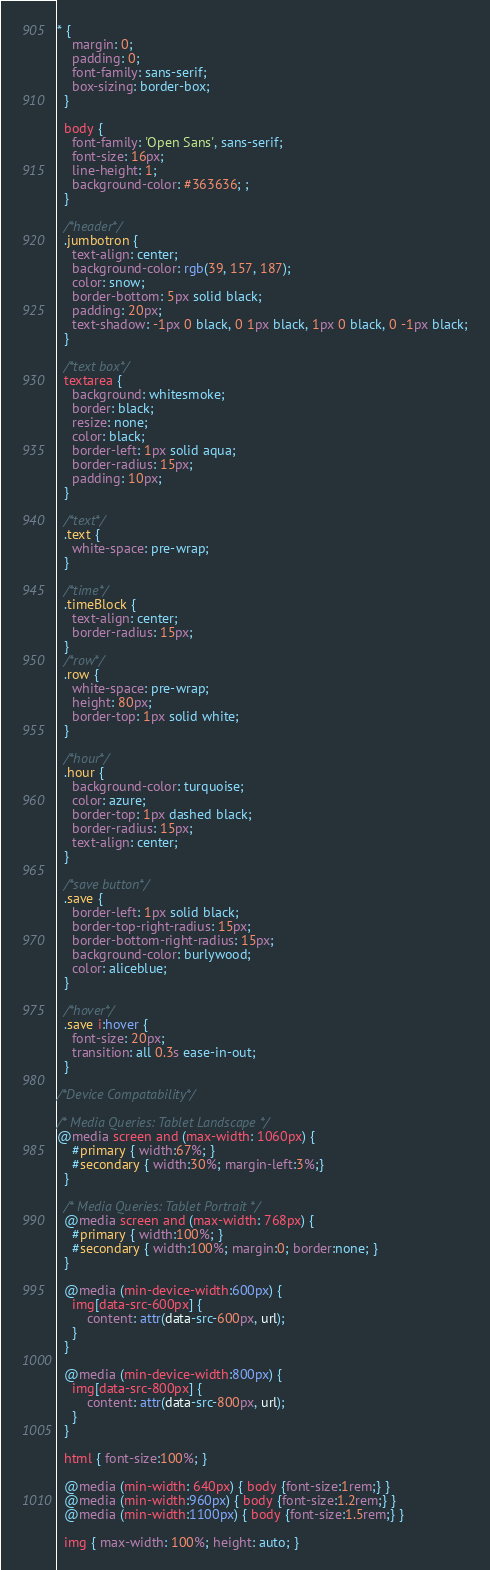Convert code to text. <code><loc_0><loc_0><loc_500><loc_500><_CSS_>* {
    margin: 0;
    padding: 0;
    font-family: sans-serif;
    box-sizing: border-box;
  }
  
  body {
    font-family: 'Open Sans', sans-serif;
    font-size: 16px;
    line-height: 1;
    background-color: #363636; ;
  }
  
  /*header*/
  .jumbotron {
    text-align: center;
    background-color: rgb(39, 157, 187);
    color: snow;
    border-bottom: 5px solid black;
    padding: 20px;
    text-shadow: -1px 0 black, 0 1px black, 1px 0 black, 0 -1px black;
  }
  
  /*text box*/
  textarea {
    background: whitesmoke;
    border: black;
    resize: none;
    color: black;
    border-left: 1px solid aqua;
    border-radius: 15px;
    padding: 10px;
  }
  
  /*text*/
  .text {
    white-space: pre-wrap;
  }
  
  /*time*/
  .timeBlock {
    text-align: center;
    border-radius: 15px;
  }
  /*row*/
  .row {
    white-space: pre-wrap;
    height: 80px;
    border-top: 1px solid white;
  }
  
  /*hour*/
  .hour {
    background-color: turquoise;
    color: azure;
    border-top: 1px dashed black;
    border-radius: 15px;
    text-align: center;
  }
  
  /*save button*/
  .save {
    border-left: 1px solid black;
    border-top-right-radius: 15px;
    border-bottom-right-radius: 15px;
    background-color: burlywood;
    color: aliceblue;
  }
  
  /*hover*/
  .save i:hover {
    font-size: 20px;
    transition: all 0.3s ease-in-out;
  }

/*Device Compatability*/

/* Media Queries: Tablet Landscape */
@media screen and (max-width: 1060px) {
    #primary { width:67%; }
    #secondary { width:30%; margin-left:3%;}  
  }
  
  /* Media Queries: Tablet Portrait */
  @media screen and (max-width: 768px) {
    #primary { width:100%; }
    #secondary { width:100%; margin:0; border:none; }
  }
  
  @media (min-device-width:600px) {
    img[data-src-600px] {
        content: attr(data-src-600px, url);
    }
  }
  
  @media (min-device-width:800px) {
    img[data-src-800px] {
        content: attr(data-src-800px, url);
    }
  }
  
  html { font-size:100%; }
  
  @media (min-width: 640px) { body {font-size:1rem;} } 
  @media (min-width:960px) { body {font-size:1.2rem;} } 
  @media (min-width:1100px) { body {font-size:1.5rem;} } 
  
  img { max-width: 100%; height: auto; }</code> 